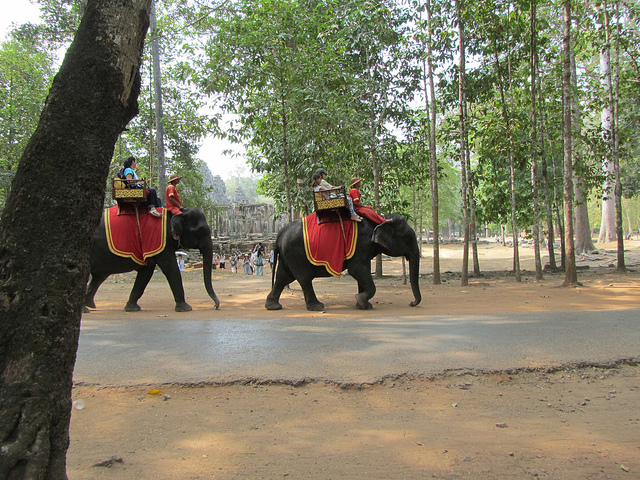Can you tell me more about the trees visible in the background? The trees have tall, slender trunks, and the foliage begins quite high off the ground, indicative of a forested area that may be well maintained to accommodate foot traffic and preserve the natural beauty around a historical site, allowing visitors to enjoy both the cultural and natural aspects of the location. 